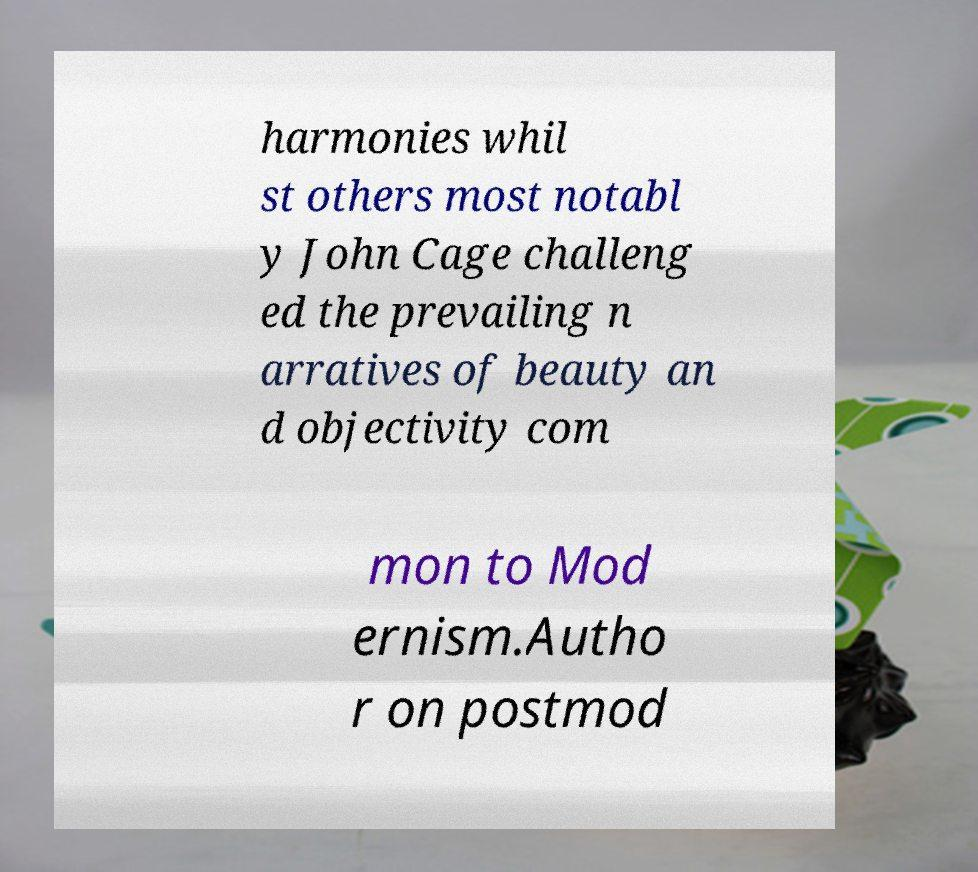Please read and relay the text visible in this image. What does it say? harmonies whil st others most notabl y John Cage challeng ed the prevailing n arratives of beauty an d objectivity com mon to Mod ernism.Autho r on postmod 